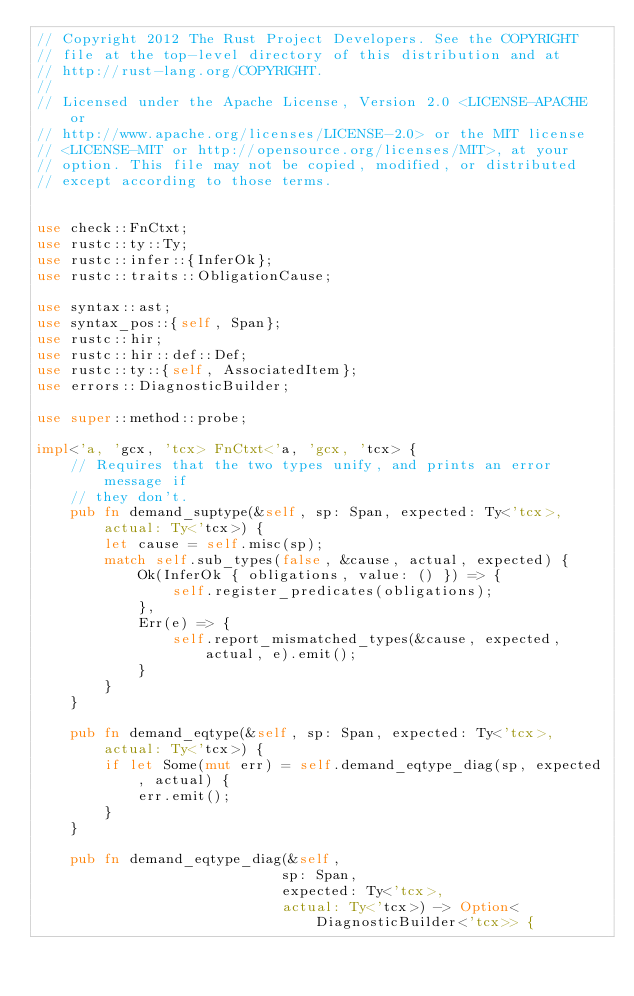Convert code to text. <code><loc_0><loc_0><loc_500><loc_500><_Rust_>// Copyright 2012 The Rust Project Developers. See the COPYRIGHT
// file at the top-level directory of this distribution and at
// http://rust-lang.org/COPYRIGHT.
//
// Licensed under the Apache License, Version 2.0 <LICENSE-APACHE or
// http://www.apache.org/licenses/LICENSE-2.0> or the MIT license
// <LICENSE-MIT or http://opensource.org/licenses/MIT>, at your
// option. This file may not be copied, modified, or distributed
// except according to those terms.


use check::FnCtxt;
use rustc::ty::Ty;
use rustc::infer::{InferOk};
use rustc::traits::ObligationCause;

use syntax::ast;
use syntax_pos::{self, Span};
use rustc::hir;
use rustc::hir::def::Def;
use rustc::ty::{self, AssociatedItem};
use errors::DiagnosticBuilder;

use super::method::probe;

impl<'a, 'gcx, 'tcx> FnCtxt<'a, 'gcx, 'tcx> {
    // Requires that the two types unify, and prints an error message if
    // they don't.
    pub fn demand_suptype(&self, sp: Span, expected: Ty<'tcx>, actual: Ty<'tcx>) {
        let cause = self.misc(sp);
        match self.sub_types(false, &cause, actual, expected) {
            Ok(InferOk { obligations, value: () }) => {
                self.register_predicates(obligations);
            },
            Err(e) => {
                self.report_mismatched_types(&cause, expected, actual, e).emit();
            }
        }
    }

    pub fn demand_eqtype(&self, sp: Span, expected: Ty<'tcx>, actual: Ty<'tcx>) {
        if let Some(mut err) = self.demand_eqtype_diag(sp, expected, actual) {
            err.emit();
        }
    }

    pub fn demand_eqtype_diag(&self,
                             sp: Span,
                             expected: Ty<'tcx>,
                             actual: Ty<'tcx>) -> Option<DiagnosticBuilder<'tcx>> {</code> 